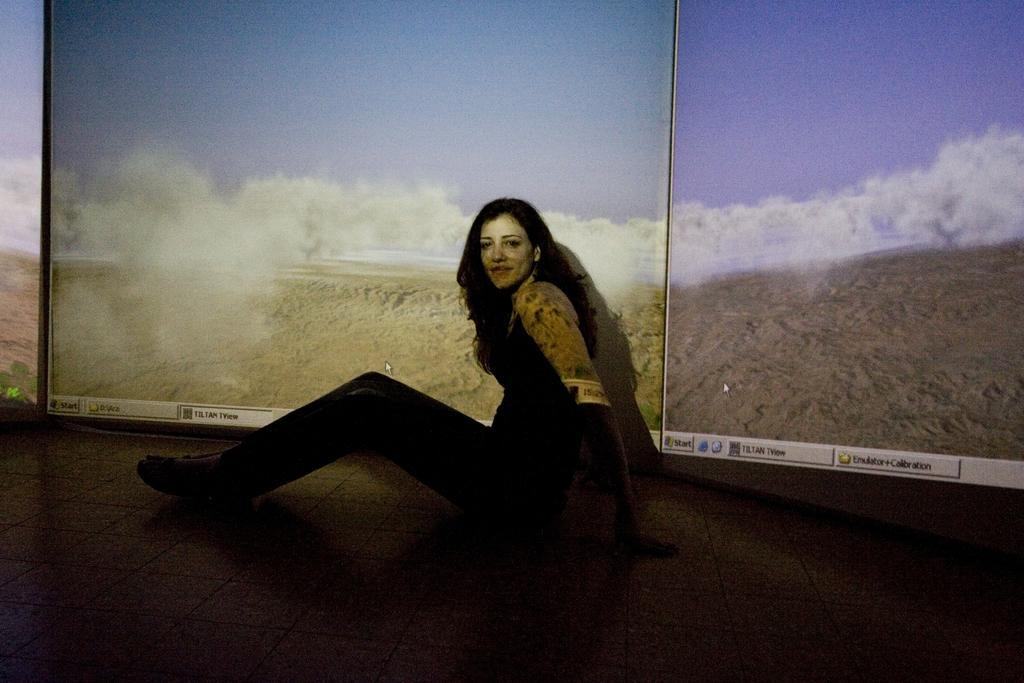Who is the main subject in the image? There is a woman in the image. What is the woman doing in the image? The woman is sitting on the floor. What is the woman's facial expression in the image? The woman is smiling. What can be seen in the background of the image? There are clouds visible in the sky in the background of the image. What type of crack is visible on the woman's face in the image? There is no crack visible on the woman's face in the image. Who is the woman's partner in the image? The image does not show any other person, so there is no partner present. 